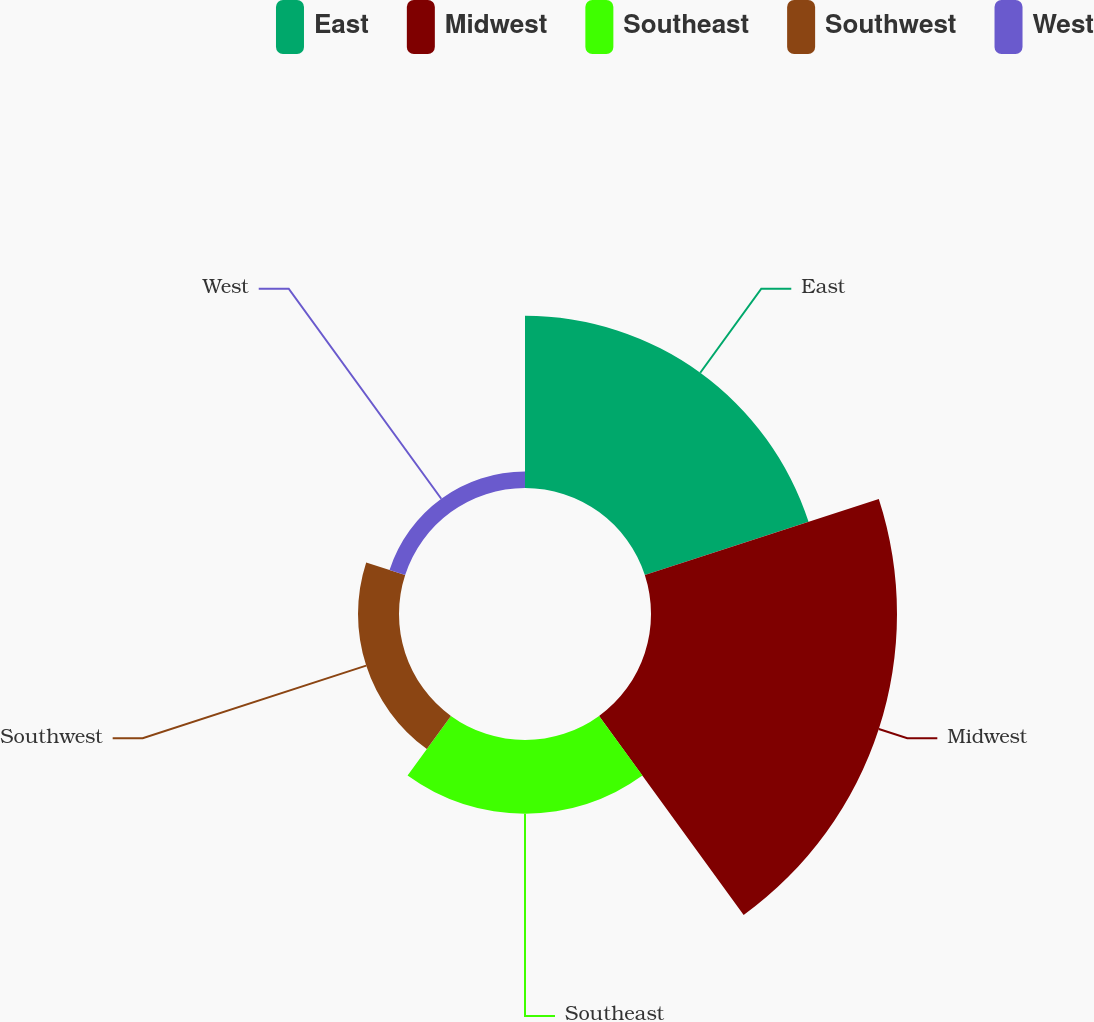<chart> <loc_0><loc_0><loc_500><loc_500><pie_chart><fcel>East<fcel>Midwest<fcel>Southeast<fcel>Southwest<fcel>West<nl><fcel>31.34%<fcel>44.78%<fcel>13.43%<fcel>7.46%<fcel>2.99%<nl></chart> 